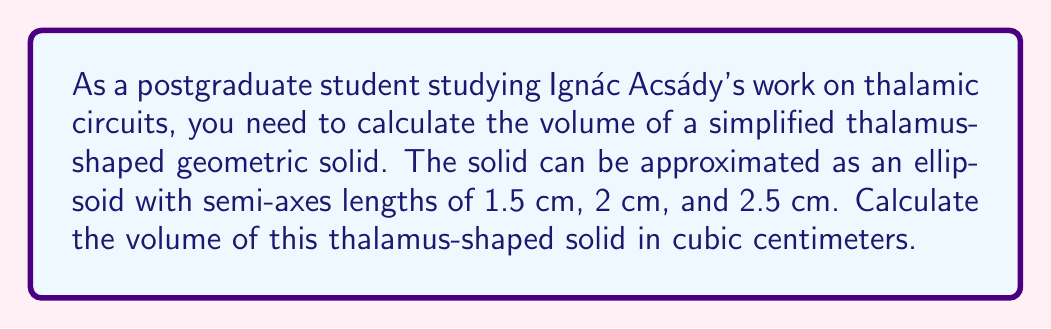Give your solution to this math problem. To calculate the volume of an ellipsoid, we can use the formula:

$$V = \frac{4}{3}\pi abc$$

Where $a$, $b$, and $c$ are the lengths of the semi-axes.

Given:
$a = 1.5$ cm
$b = 2$ cm
$c = 2.5$ cm

Step 1: Substitute the values into the formula:
$$V = \frac{4}{3}\pi(1.5)(2)(2.5)$$

Step 2: Multiply the values inside the parentheses:
$$V = \frac{4}{3}\pi(7.5)$$

Step 3: Multiply by $\frac{4}{3}$:
$$V = 10\pi$$

Step 4: Calculate the final value (rounded to two decimal places):
$$V \approx 31.42\text{ cm}^3$$

This approximation of the thalamus as an ellipsoid is relevant to Acsády's work, as it provides a simplified model for understanding the spatial relationships of thalamic circuits.
Answer: $31.42\text{ cm}^3$ 